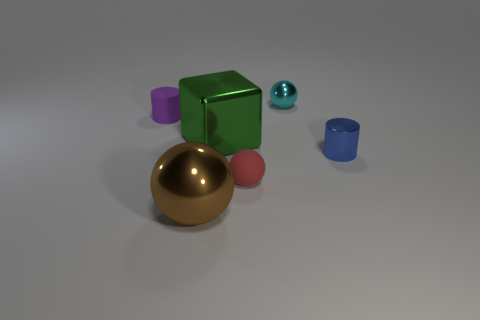Add 3 cyan cylinders. How many objects exist? 9 Subtract all cubes. How many objects are left? 5 Subtract 0 yellow cylinders. How many objects are left? 6 Subtract all tiny cylinders. Subtract all brown objects. How many objects are left? 3 Add 4 tiny blue cylinders. How many tiny blue cylinders are left? 5 Add 1 red metallic balls. How many red metallic balls exist? 1 